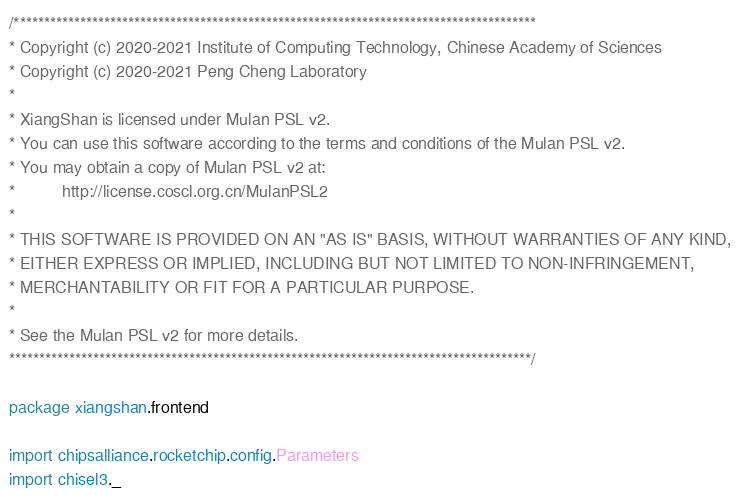Convert code to text. <code><loc_0><loc_0><loc_500><loc_500><_Scala_>/***************************************************************************************
* Copyright (c) 2020-2021 Institute of Computing Technology, Chinese Academy of Sciences
* Copyright (c) 2020-2021 Peng Cheng Laboratory
*
* XiangShan is licensed under Mulan PSL v2.
* You can use this software according to the terms and conditions of the Mulan PSL v2.
* You may obtain a copy of Mulan PSL v2 at:
*          http://license.coscl.org.cn/MulanPSL2
*
* THIS SOFTWARE IS PROVIDED ON AN "AS IS" BASIS, WITHOUT WARRANTIES OF ANY KIND,
* EITHER EXPRESS OR IMPLIED, INCLUDING BUT NOT LIMITED TO NON-INFRINGEMENT,
* MERCHANTABILITY OR FIT FOR A PARTICULAR PURPOSE.
*
* See the Mulan PSL v2 for more details.
***************************************************************************************/

package xiangshan.frontend

import chipsalliance.rocketchip.config.Parameters
import chisel3._</code> 